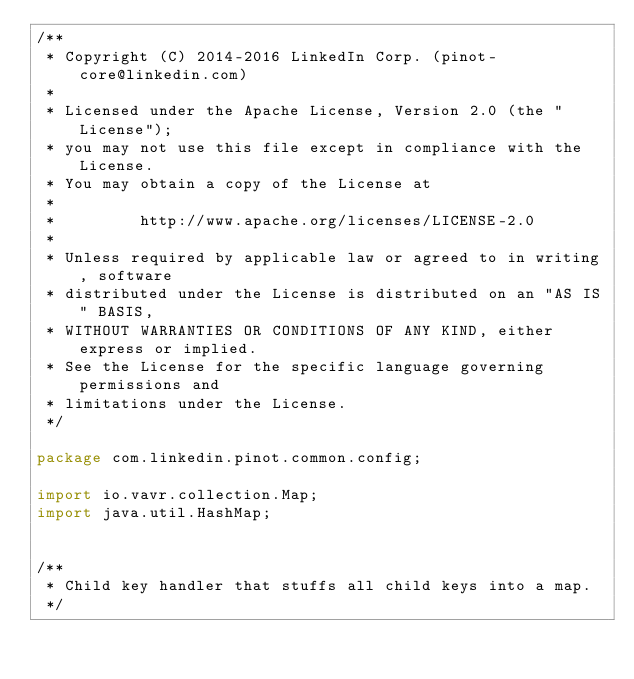Convert code to text. <code><loc_0><loc_0><loc_500><loc_500><_Java_>/**
 * Copyright (C) 2014-2016 LinkedIn Corp. (pinot-core@linkedin.com)
 *
 * Licensed under the Apache License, Version 2.0 (the "License");
 * you may not use this file except in compliance with the License.
 * You may obtain a copy of the License at
 *
 *         http://www.apache.org/licenses/LICENSE-2.0
 *
 * Unless required by applicable law or agreed to in writing, software
 * distributed under the License is distributed on an "AS IS" BASIS,
 * WITHOUT WARRANTIES OR CONDITIONS OF ANY KIND, either express or implied.
 * See the License for the specific language governing permissions and
 * limitations under the License.
 */

package com.linkedin.pinot.common.config;

import io.vavr.collection.Map;
import java.util.HashMap;


/**
 * Child key handler that stuffs all child keys into a map.
 */</code> 